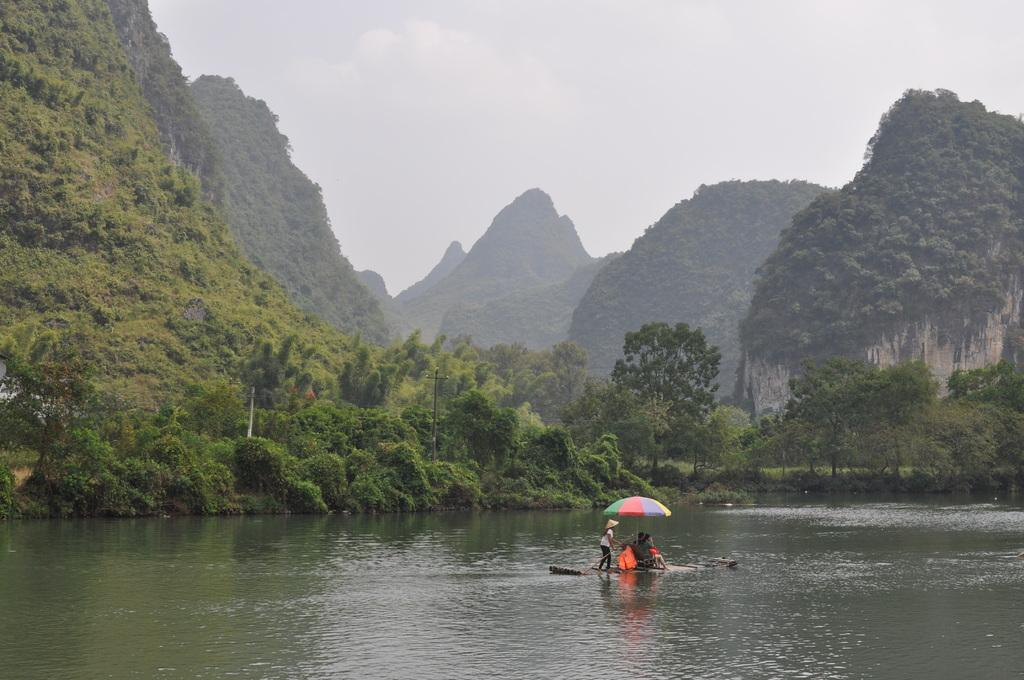How many persons are in the image? There are persons in the image, but the exact number is not specified. What are the persons on in the image? The persons are on a handmade boat. What is present on the handmade boat? There is an umbrella on the handmade boat. What can be seen in the middle of the image? There are trees and hills in the middle of the image. What is visible at the top of the image? The sky is visible at the top of the image. What type of turkey can be seen playing baseball in the image? There is no turkey or baseball present in the image; it features persons on a handmade boat with an umbrella, surrounded by trees, hills, and the sky. 